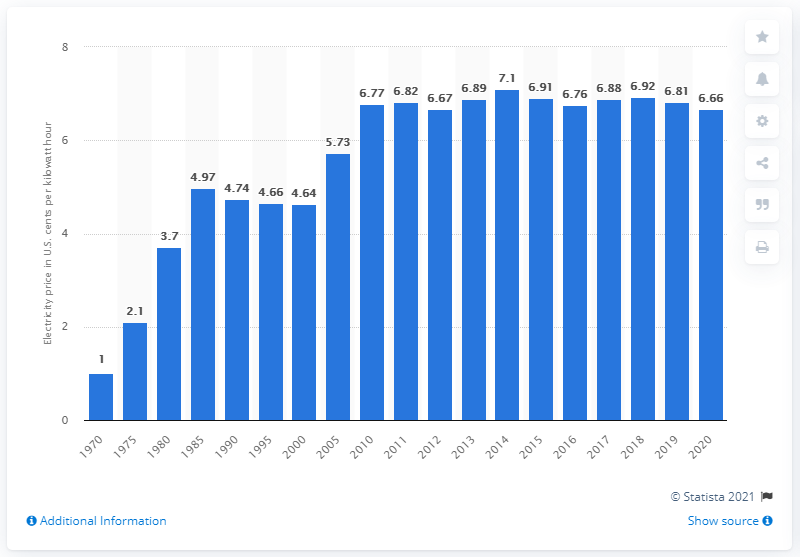Specify some key components in this picture. In 2020, the average U.S. cent per kilowatt hour was 6.66 cents. In 2014, the average cost of electricity in the United States was 7.1 cents per kilowatt-hour. 